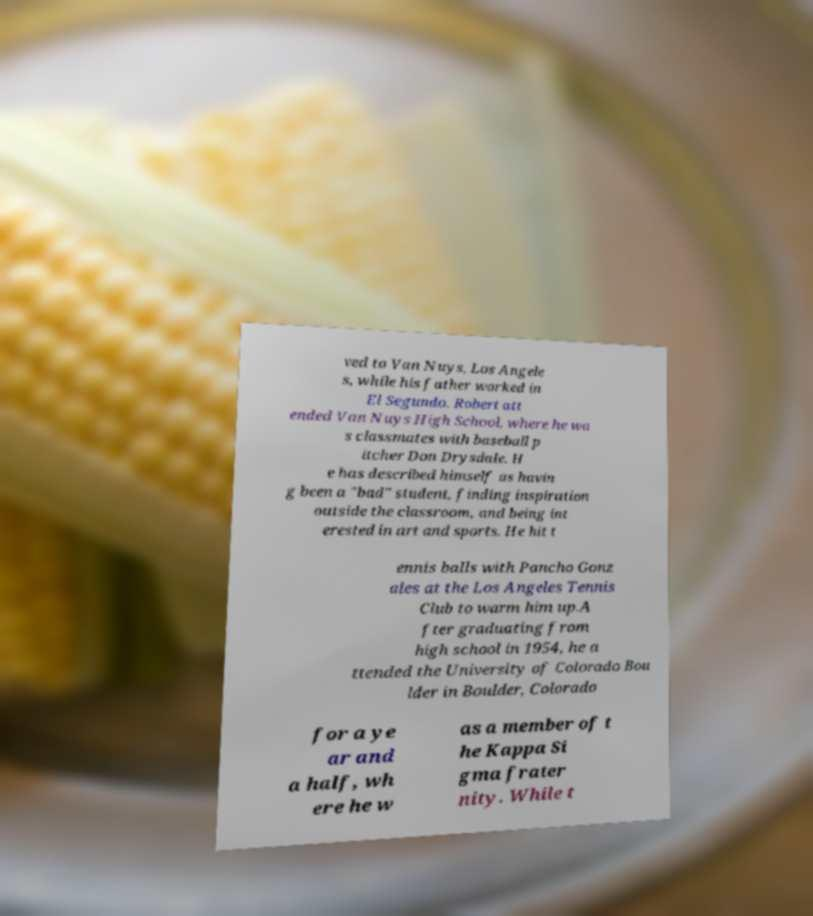What messages or text are displayed in this image? I need them in a readable, typed format. ved to Van Nuys, Los Angele s, while his father worked in El Segundo. Robert att ended Van Nuys High School, where he wa s classmates with baseball p itcher Don Drysdale. H e has described himself as havin g been a "bad" student, finding inspiration outside the classroom, and being int erested in art and sports. He hit t ennis balls with Pancho Gonz ales at the Los Angeles Tennis Club to warm him up.A fter graduating from high school in 1954, he a ttended the University of Colorado Bou lder in Boulder, Colorado for a ye ar and a half, wh ere he w as a member of t he Kappa Si gma frater nity. While t 